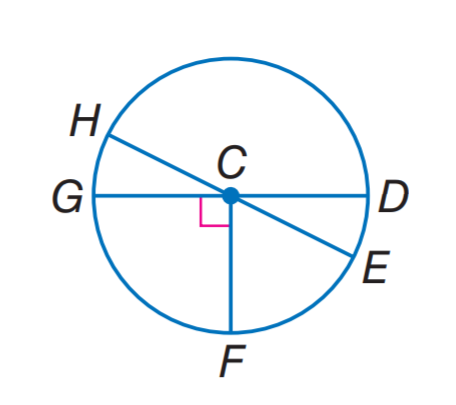Answer the mathemtical geometry problem and directly provide the correct option letter.
Question: In \odot C, m \angle H C G = 2 x and m \angle H C D = 6 x + 28, find m \widehat E F.
Choices: A: 38 B: 52 C: 68 D: 142 B 